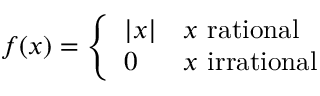<formula> <loc_0><loc_0><loc_500><loc_500>f ( x ) = { \left \{ \begin{array} { l l } { | x | } & { x { r a t i o n a l } } \\ { 0 } & { x { i r r a t i o n a l } } \end{array} }</formula> 